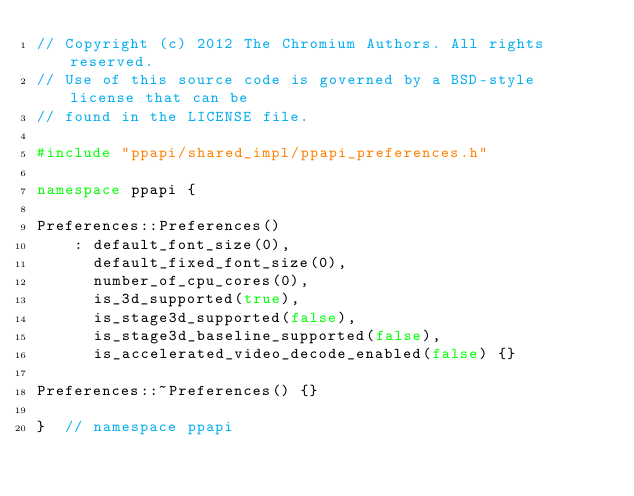<code> <loc_0><loc_0><loc_500><loc_500><_C++_>// Copyright (c) 2012 The Chromium Authors. All rights reserved.
// Use of this source code is governed by a BSD-style license that can be
// found in the LICENSE file.

#include "ppapi/shared_impl/ppapi_preferences.h"

namespace ppapi {

Preferences::Preferences()
    : default_font_size(0),
      default_fixed_font_size(0),
      number_of_cpu_cores(0),
      is_3d_supported(true),
      is_stage3d_supported(false),
      is_stage3d_baseline_supported(false),
      is_accelerated_video_decode_enabled(false) {}

Preferences::~Preferences() {}

}  // namespace ppapi
</code> 